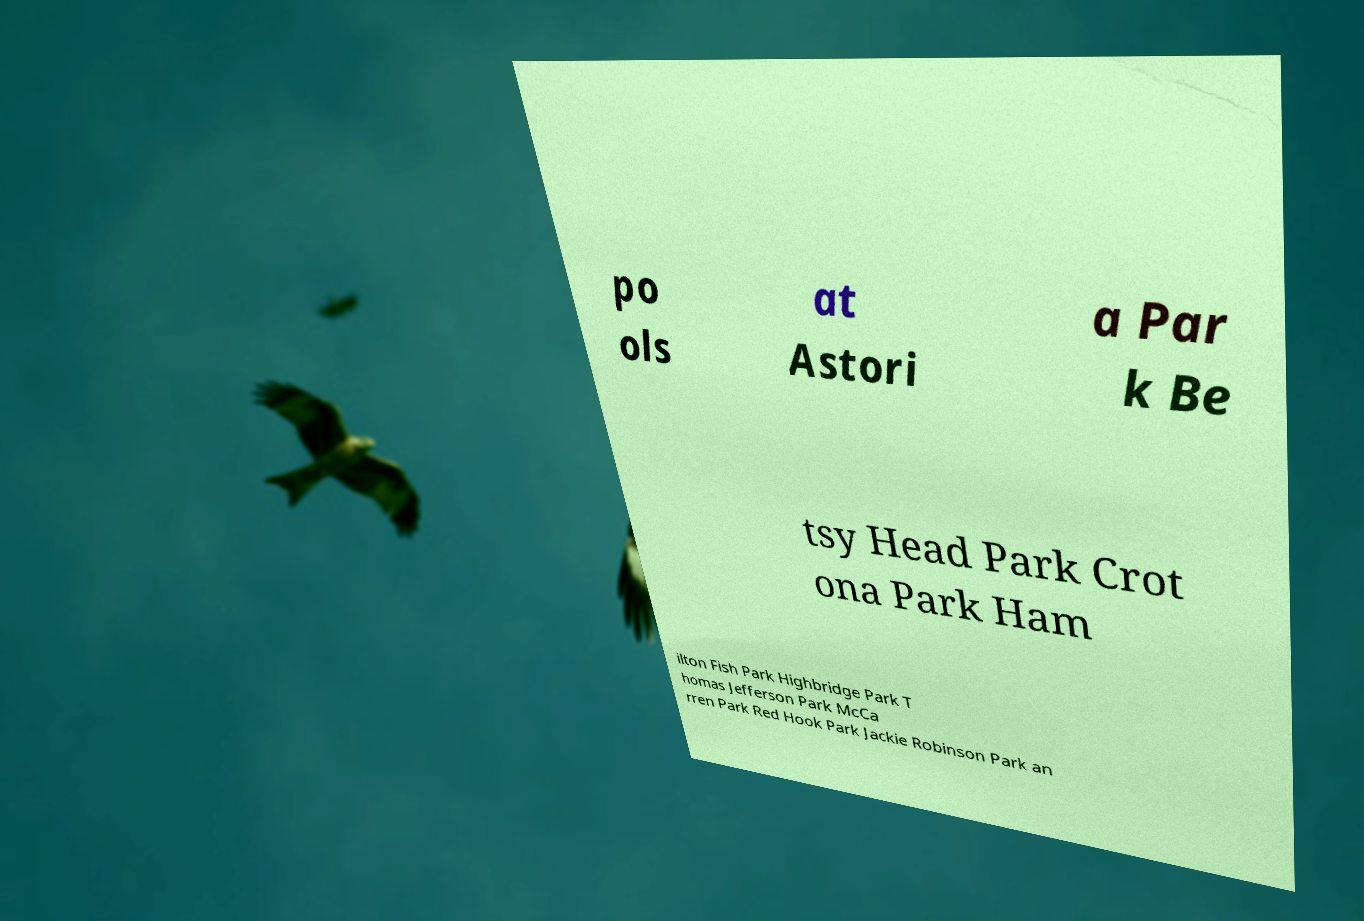For documentation purposes, I need the text within this image transcribed. Could you provide that? po ols at Astori a Par k Be tsy Head Park Crot ona Park Ham ilton Fish Park Highbridge Park T homas Jefferson Park McCa rren Park Red Hook Park Jackie Robinson Park an 